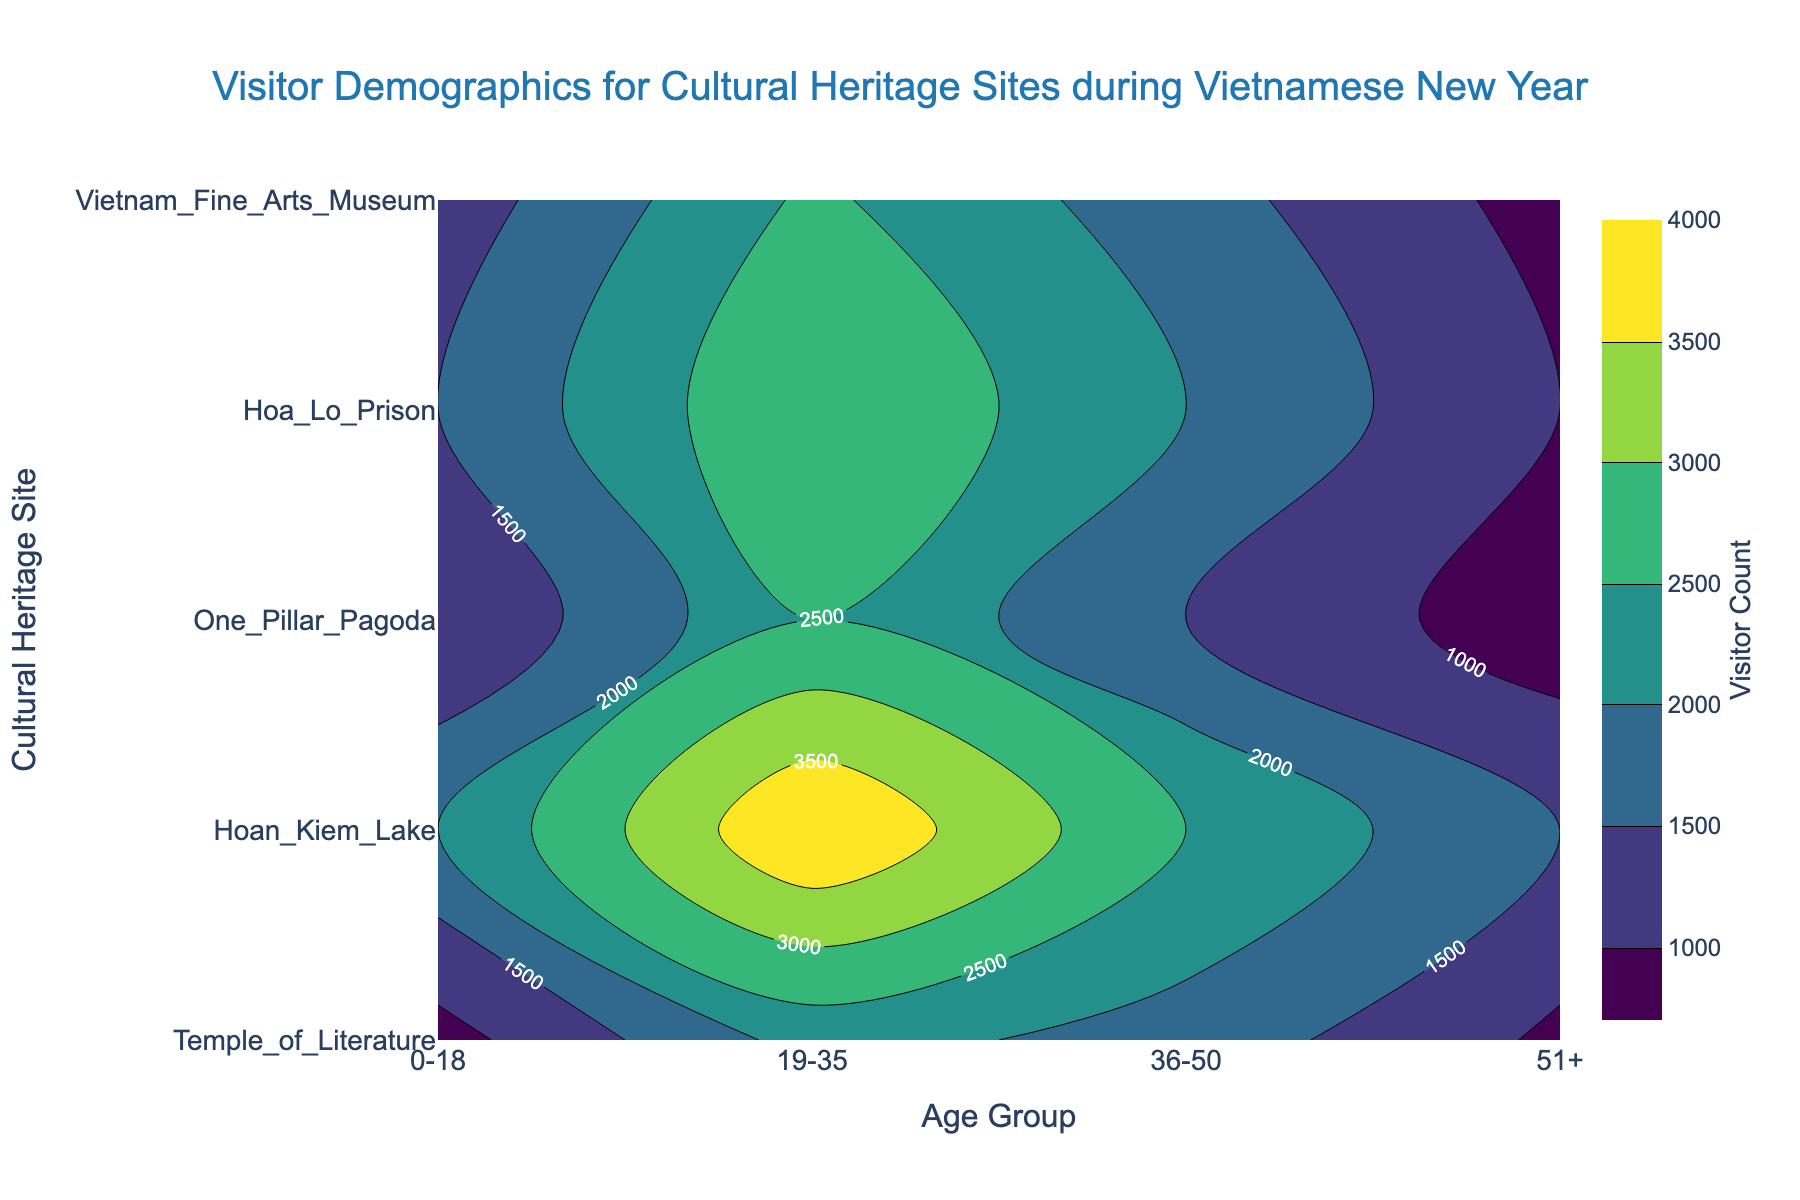What's the title of the figure? The title can be found at the top of the figure. It is "Visitor Demographics for Cultural Heritage Sites during Vietnamese New Year".
Answer: Visitor Demographics for Cultural Heritage Sites during Vietnamese New Year How many age groups are there displayed in the figure? By looking at the x-axis labels, there are four distinct age groups: "0-18", "19-35", "36-50", and "51+".
Answer: 4 Which site has the highest visitor count for the age group 19-35? By examining the contour plot for the age group "19-35", Hoan Kiem Lake shows the highest visitor count with a value of 4000.
Answer: Hoan Kiem Lake What's the total visitor count for Temple of Literature across all age groups? To find the total visitor count for Temple of Literature, sum the values for each age group: 1500 (0-18) + 3000 (19-35) + 2000 (36-50) + 1000 (51+) = 7500.
Answer: 7500 Which age group visited Hoa Lo Prison the least? By comparing the visitor counts of each age group for Hoa Lo Prison, the age group "0-18" has the lowest count with 800 visitors.
Answer: 0-18 How does the visitor count for the age group 36-50 compare between Temple of Literature and One Pillar Pagoda? For the age group "36-50", Temple of Literature has 2000 visitors while One Pillar Pagoda has 1500 visitors. Thus, Temple of Literature has 500 more visitors than One Pillar Pagoda.
Answer: Temple of Literature has 500 more Which cultural heritage site shows the lowest visitor count across all age groups? By reviewing the lowest visitor count values for each site: Temple of Literature (1000), Hoan Kiem Lake (1500), One Pillar Pagoda (700), Hoa Lo Prison (800), and Vietnam Fine Arts Museum (800), One Pillar Pagoda has the lowest count with 700 visitors.
Answer: One Pillar Pagoda What is the average number of visitors for the age group 51+ across all sites? Sum the visitors for the age group "51+" across all sites and divide by the number of sites: (1000 + 1500 + 700 + 900 + 800) / 5 = 4900 / 5 = 980.
Answer: 980 Which age group has the most variation in visitor counts across all sites? By inspecting the contour plot, the age group "19-35" shows the most variation with counts ranging from 2200 to 4000. This suggests a wider spread compared to other age groups.
Answer: 19-35 What is the median visitor count for the age group 0-18 across all sites? The visitor counts for the age group "0-18" are: 1500, 2000, 1000, 800, and 1200. When sorted (800, 1000, 1200, 1500, 2000), the median value is the middle one: 1200.
Answer: 1200 